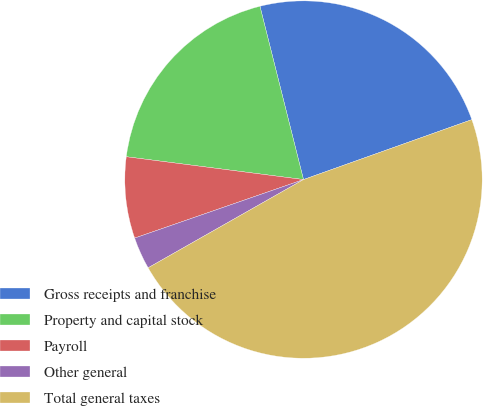Convert chart to OTSL. <chart><loc_0><loc_0><loc_500><loc_500><pie_chart><fcel>Gross receipts and franchise<fcel>Property and capital stock<fcel>Payroll<fcel>Other general<fcel>Total general taxes<nl><fcel>23.47%<fcel>19.04%<fcel>7.35%<fcel>2.91%<fcel>47.22%<nl></chart> 